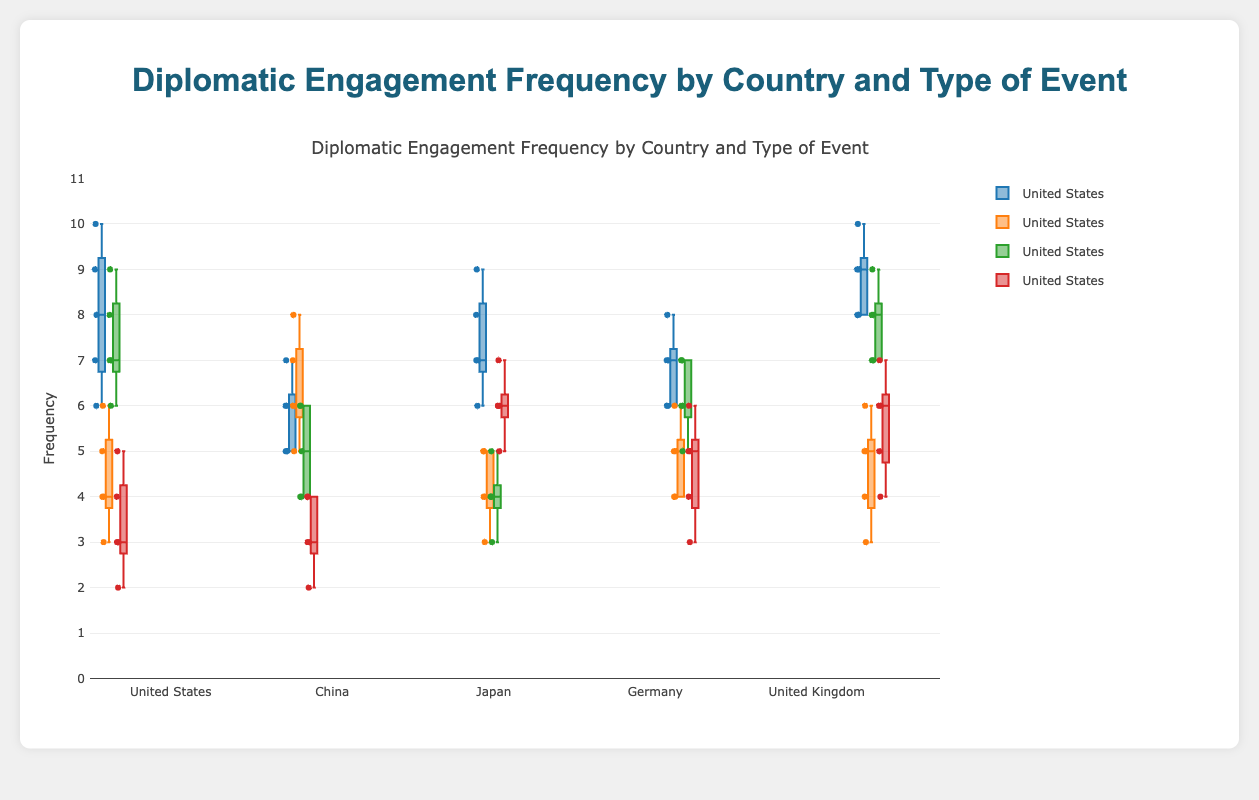What is the title of the figure? The title of the figure is located at the top and it clearly states the subject matter of the plot.
Answer: Diplomatic Engagement Frequency by Country and Type of Event What are the colors used to differentiate the types of events? The figure uses different colors for each event type, which can be seen in the legend on the right side of the plot. 'BilateralTalks' is blue, 'MultilateralSummits' is orange, 'TradeNegotiations' is green, and 'CulturalExchanges' is red.
Answer: Blue, Orange, Green, Red How many countries are represented in the figure? Each box plot corresponds to a different country, and we can count the number of distinct box plots for each event type to determine the number of countries.
Answer: 5 What is the range of the y-axis? The range of the y-axis is displayed along the vertical axis and typically goes from the minimum to the maximum value of the data.
Answer: 0 to 11 Which country has the highest median value for Bilateral Talks? To answer this question, look at the boxes corresponding to 'BilateralTalks' and identify which box has the highest line (median line) within the box.
Answer: United Kingdom Which event type has the most variability within the United States? Variability can be observed through the boxplot's spread (height of the box). The event type with the tallest box or largest interquartile range has the most variability.
Answer: Bilateral Talks Among the five countries, which one has the least frequent Trade Negotiations on average? Examine the position of the median lines within the boxes for 'TradeNegotiations' and identify which is the lowest.
Answer: China What is the median frequency of Cultural Exchanges for Japan? The median is represented by the line inside the box. For Japan's 'CulturalExchanges', this value can be read directly from the median line.
Answer: 6 Which event type and for which country shows the smallest interquartile range (IQR)? The IQR is the height of each box within the plot; the smallest box height corresponds to the smallest IQR. Identify the smallest box across all event types and countries.
Answer: Multilateral Summits for Japan Which country participates in Multilateral Summits more frequently, China or Germany? Compare the medians of the 'MultilateralSummits' boxes for both China and Germany to see which median is higher.
Answer: China 